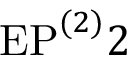Convert formula to latex. <formula><loc_0><loc_0><loc_500><loc_500>E P ^ { ( 2 ) } 2</formula> 